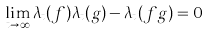<formula> <loc_0><loc_0><loc_500><loc_500>\lim _ { t \to \infty } \lambda _ { t } ( f ) \lambda _ { t } ( g ) - \lambda _ { t } ( f g ) = 0</formula> 